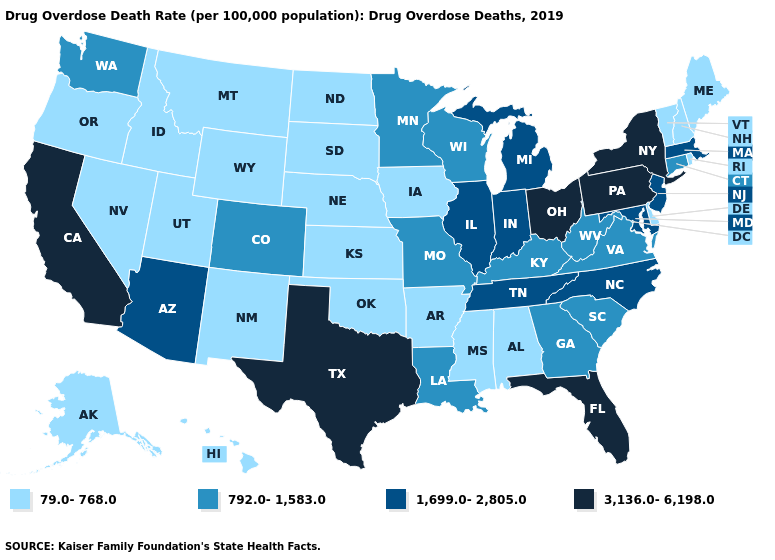Does Nebraska have the lowest value in the USA?
Answer briefly. Yes. Does Kansas have the same value as Hawaii?
Answer briefly. Yes. Which states have the lowest value in the USA?
Answer briefly. Alabama, Alaska, Arkansas, Delaware, Hawaii, Idaho, Iowa, Kansas, Maine, Mississippi, Montana, Nebraska, Nevada, New Hampshire, New Mexico, North Dakota, Oklahoma, Oregon, Rhode Island, South Dakota, Utah, Vermont, Wyoming. What is the value of Tennessee?
Answer briefly. 1,699.0-2,805.0. Is the legend a continuous bar?
Keep it brief. No. Does South Carolina have the lowest value in the South?
Concise answer only. No. Does Mississippi have the highest value in the South?
Keep it brief. No. What is the value of Missouri?
Concise answer only. 792.0-1,583.0. What is the value of South Carolina?
Keep it brief. 792.0-1,583.0. Among the states that border Michigan , does Indiana have the highest value?
Quick response, please. No. Among the states that border Connecticut , which have the highest value?
Quick response, please. New York. Name the states that have a value in the range 792.0-1,583.0?
Keep it brief. Colorado, Connecticut, Georgia, Kentucky, Louisiana, Minnesota, Missouri, South Carolina, Virginia, Washington, West Virginia, Wisconsin. Does New Mexico have the lowest value in the USA?
Short answer required. Yes. Among the states that border Connecticut , which have the lowest value?
Be succinct. Rhode Island. Name the states that have a value in the range 79.0-768.0?
Give a very brief answer. Alabama, Alaska, Arkansas, Delaware, Hawaii, Idaho, Iowa, Kansas, Maine, Mississippi, Montana, Nebraska, Nevada, New Hampshire, New Mexico, North Dakota, Oklahoma, Oregon, Rhode Island, South Dakota, Utah, Vermont, Wyoming. 